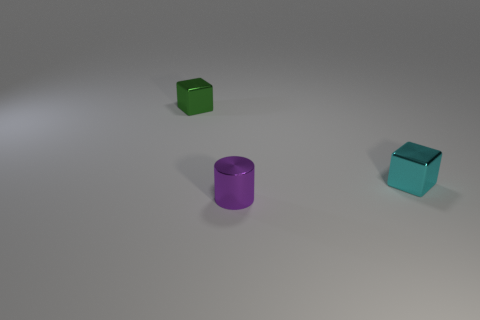Add 2 tiny cyan shiny spheres. How many objects exist? 5 Subtract 1 cylinders. How many cylinders are left? 0 Subtract all cyan blocks. How many blocks are left? 1 Subtract all cylinders. How many objects are left? 2 Subtract all green objects. Subtract all small purple cylinders. How many objects are left? 1 Add 2 small green objects. How many small green objects are left? 3 Add 2 big metal balls. How many big metal balls exist? 2 Subtract 1 cyan cubes. How many objects are left? 2 Subtract all yellow blocks. Subtract all yellow balls. How many blocks are left? 2 Subtract all blue cylinders. How many yellow blocks are left? 0 